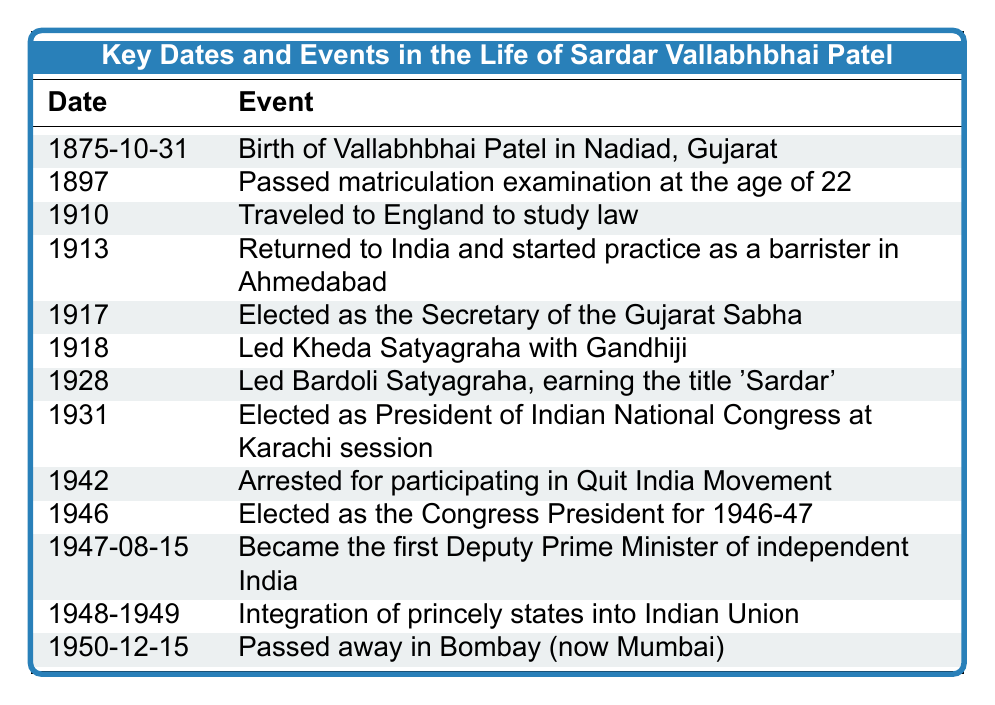What is the date of Sardar Vallabhbhai Patel's birth? The table lists the events in order of date. The first entry indicates that Vallabhbhai Patel was born on 1875-10-31.
Answer: 1875-10-31 Which event occurred in 1918? By scanning the table, the event listed for the year 1918 is "Led Kheda Satyagraha with Gandhiji."
Answer: Led Kheda Satyagraha with Gandhiji How many events are recorded before 1940? The table contains events chronologically from 1875 to 1950. By counting, there are 10 events listed before 1940.
Answer: 10 Did Sardar Vallabhbhai Patel become the Deputy Prime Minister before or after 1947? The table indicates that he became the Deputy Prime Minister on 1947-08-15, which is in 1947, thus he became Deputy Prime Minister in 1947.
Answer: After 1947 Which two events are closest in time? Observing the table, the events "Integration of princely states into Indian Union" (1948-1949) and "Became the first Deputy Prime Minister of independent India" (1947-08-15) are the closest together, occurring only a year or so apart.
Answer: Integration of princely states into Indian Union and Became Deputy Prime Minister How many years did Sardar Vallabhbhai Patel practice law before leading the Kheda Satyagraha? Patel returned to India and started practicing as a barrister in 1913 and led the Kheda Satyagraha in 1918. The difference is 1918 - 1913 = 5 years.
Answer: 5 years Was Sardar Vallabhbhai Patel arrested for participating in the Quit India Movement? The table clearly states that he was arrested in 1942 for participating in the Quit India Movement, confirming the event occurred.
Answer: Yes What title did Sardar Vallabhbhai Patel earn in 1928? The event in 1928 mentions he led the Bardoli Satyagraha and earned the title 'Sardar'.
Answer: 'Sardar' What was the final entry in the table? By looking at the last entry, which lists events chronologically, the final event is "Passed away in Bombay (now Mumbai)" on 1950-12-15.
Answer: Passed away in Bombay (now Mumbai) What years are associated with Sardar Vallabhbhai Patel's involvement with the Congress Party? The years listed are 1931 (elected as President of the Indian National Congress) and 1946 (elected as Congress President for 1946-47), indicating his involvement during these two years.
Answer: 1931 and 1946 If Vallabhbhai Patel was 22 when he passed his matriculation exam, what year was he born? Since he passed the examination in 1897, subtracting 22 from 1897 gives us 1875, confirming his birth year was 1875.
Answer: 1875 